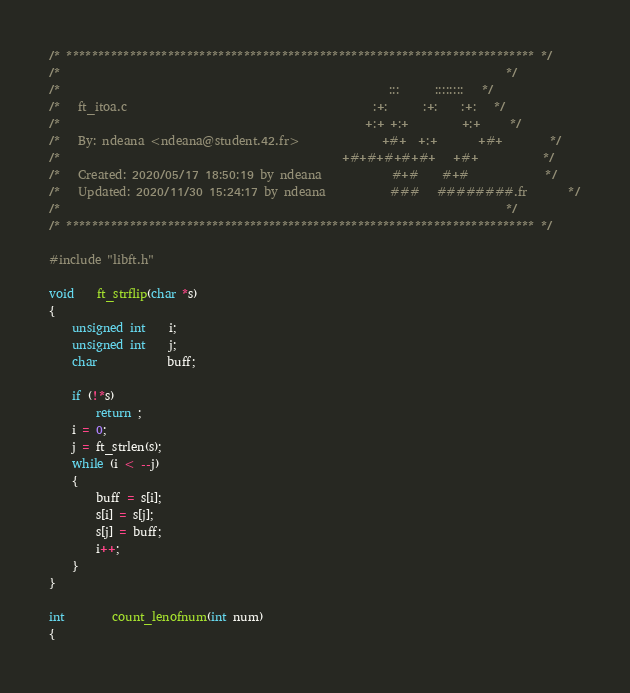<code> <loc_0><loc_0><loc_500><loc_500><_C_>/* ************************************************************************** */
/*                                                                            */
/*                                                        :::      ::::::::   */
/*   ft_itoa.c                                          :+:      :+:    :+:   */
/*                                                    +:+ +:+         +:+     */
/*   By: ndeana <ndeana@student.42.fr>              +#+  +:+       +#+        */
/*                                                +#+#+#+#+#+   +#+           */
/*   Created: 2020/05/17 18:50:19 by ndeana            #+#    #+#             */
/*   Updated: 2020/11/30 15:24:17 by ndeana           ###   ########.fr       */
/*                                                                            */
/* ************************************************************************** */

#include "libft.h"

void	ft_strflip(char *s)
{
	unsigned int	i;
	unsigned int	j;
	char			buff;

	if (!*s)
		return ;
	i = 0;
	j = ft_strlen(s);
	while (i < --j)
	{
		buff = s[i];
		s[i] = s[j];
		s[j] = buff;
		i++;
	}
}

int		count_lenofnum(int num)
{</code> 